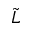Convert formula to latex. <formula><loc_0><loc_0><loc_500><loc_500>\tilde { L }</formula> 